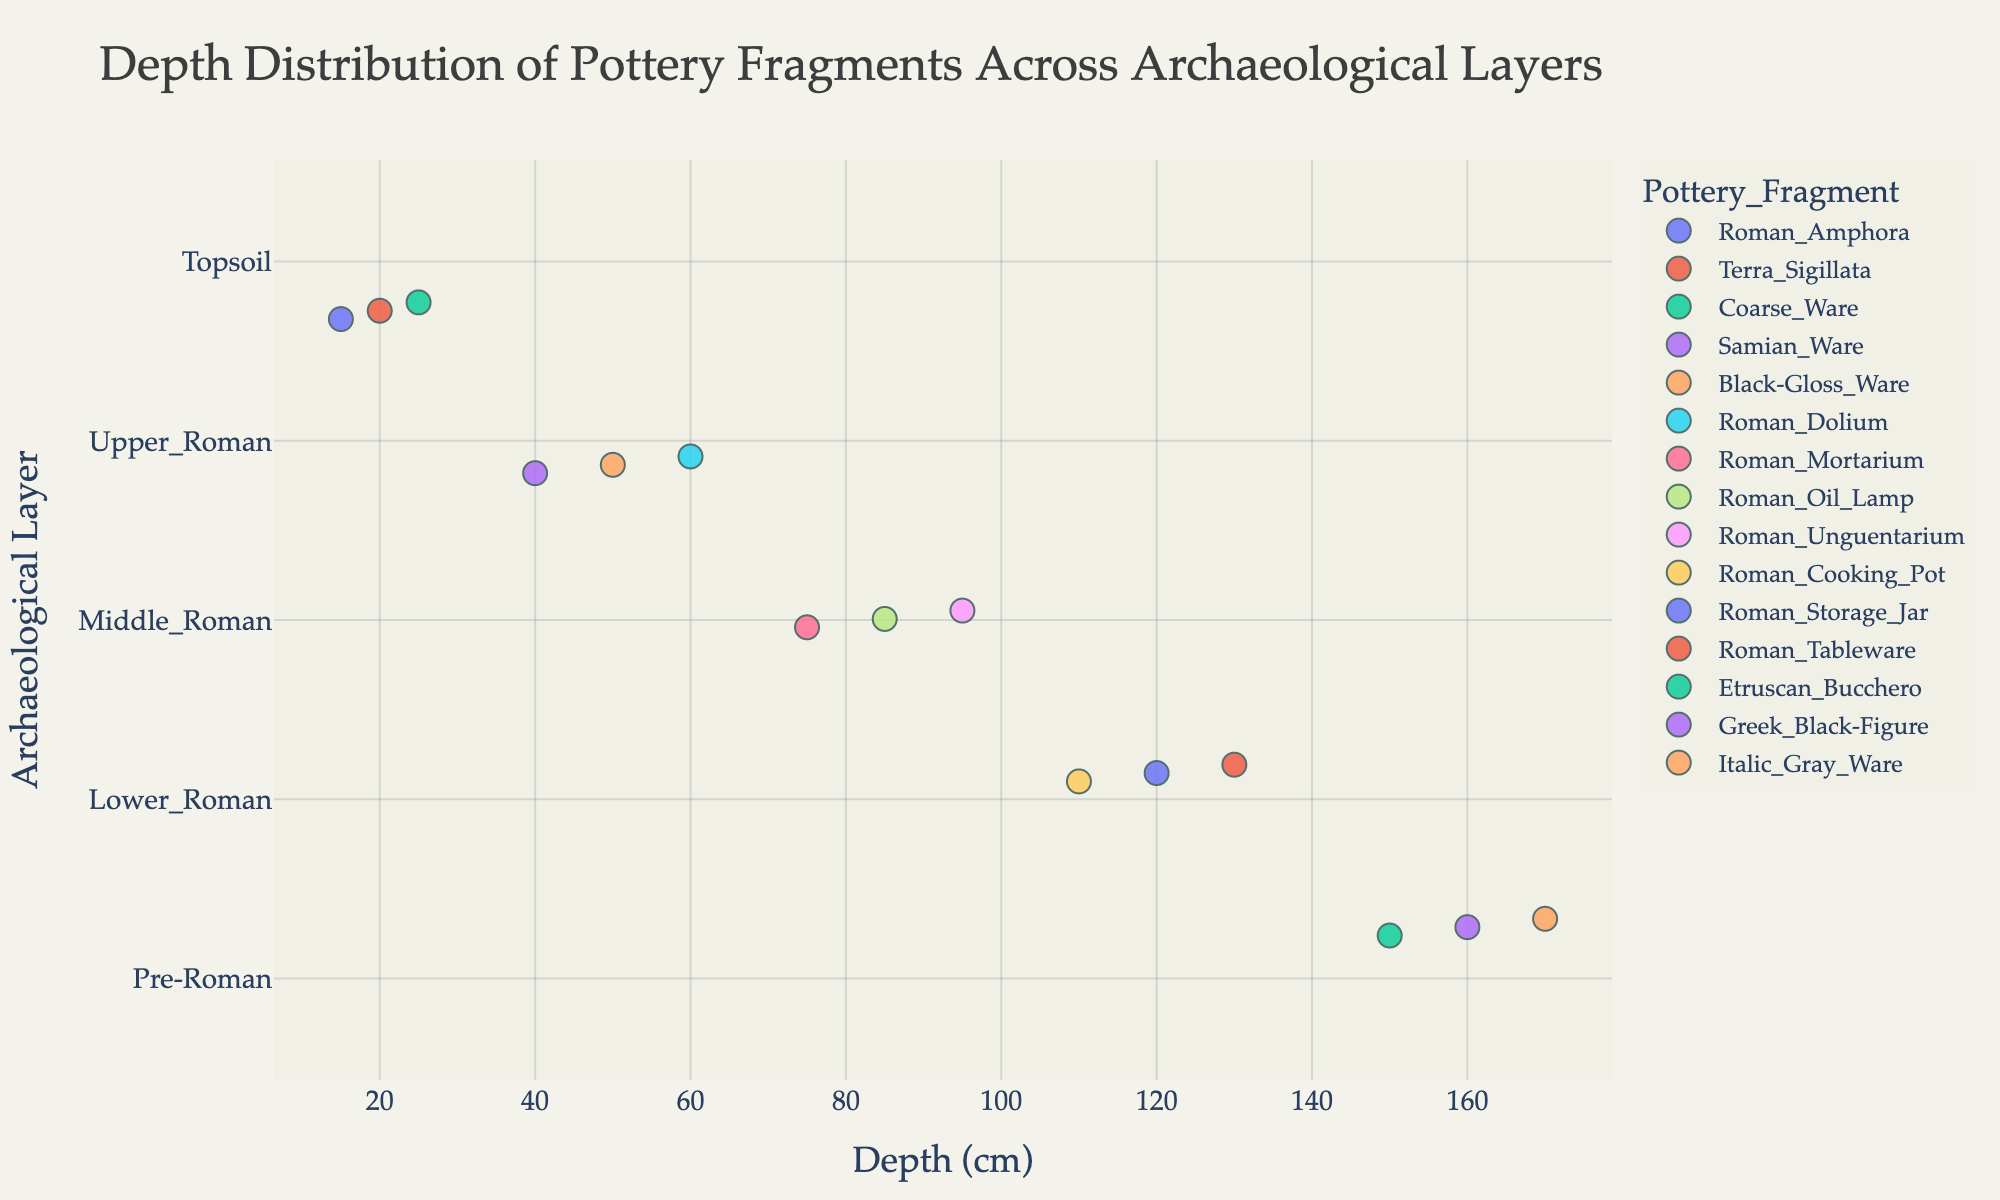What's the title of the figure? The title of the figure is usually found at the top center of the plot. In this case, it reads "Depth Distribution of Pottery Fragments Across Archaeological Layers."
Answer: Depth Distribution of Pottery Fragments Across Archaeological Layers How many layers are represented in the plot? The y-axis of the strip plot lists all the layers. To determine the number of layers, count the unique names on the y-axis. The layers listed are: Topsoil, Upper_Roman, Middle_Roman, Lower_Roman, and Pre-Roman.
Answer: 5 Which pottery fragment is found at the greatest depth? To determine the pottery fragment found at the greatest depth, look at the x-axis and identify the fragment with the highest depth value. According to the plot, the greatest depth recorded is 170 cm. The fragment found at this depth is Italic_Gray_Ware.
Answer: Italic_Gray_Ware In which layer is Roman_Oil_Lamp found? Check where the Roman_Oil_Lamp data point is located on the y-axis. In the plot, Roman_Oil_Lamp is at 85 cm depth and falls within the Middle_Roman layer.
Answer: Middle_Roman Compare the depths of pottery fragments in the Topsoil and Pre-Roman layers. Which layer has fragments at a greater depth, on average? To compare average depths, first identify the depths of pottery fragments in each layer:
Topsoil: 15, 20, 25 cm (average = (15 + 20 + 25) / 3 = 20 cm); Pre-Roman: 150, 160, 170 cm (average = (150 + 160 + 170) / 3 = 160 cm). By comparing these averages, Pre-Roman has a greater average depth.
Answer: Pre-Roman Is there any overlap in the depths of pottery fragments between the Topsoil and Upper_Roman layers? Compare the depth ranges of the two layers. Topsoil depths range between 15-25 cm, and Upper_Roman range between 40-60 cm. Since there are no common depths between these two ranges, there is no overlap.
Answer: No How many pottery fragments are found at depths greater than 100 cm? Identify and count the data points on the x-axis with depths greater than 100 cm. These depths are 110, 120, 130, 150, 160, and 170 cm. Therefore, there are six pottery fragments in this depth range.
Answer: 6 Which layer contains the highest number of pottery fragments? Count the data points within each layer on the y-axis. Layers and counts: Topsoil (3), Upper_Roman (3), Middle_Roman (3), Lower_Roman (3), Pre-Roman (3). Since all layers contain the same number of pottery fragments, there is no distinct highest number.
Answer: All layers equally What is the depth range for the Middle_Roman layer? Identify the minimum and maximum depths of the data points in the Middle_Roman layer. The depths observed are 75, 85, and 95 cm. Therefore, the range is from 75 to 95 cm.
Answer: 75 to 95 cm How does the distribution of pottery fragments in the Upper_Roman layer compare with that in the Lower_Roman layer? Compare the depth distributions of the two layers. Upper_Roman depths are 40, 50, and 60 cm, while Lower_Roman depths are 110, 120, and 130 cm. The Upper_Roman fragments are found at shallower depths than the Lower_Roman fragments.
Answer: Upper_Roman fragments are shallower 